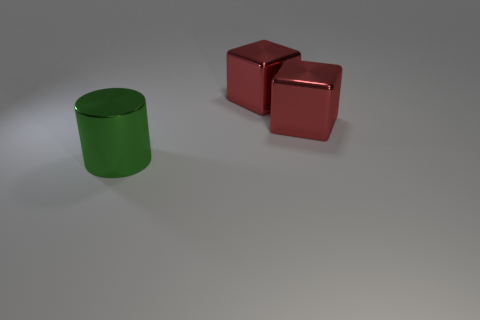What number of other objects are the same material as the green thing?
Offer a terse response. 2. What number of big objects are green cylinders or red objects?
Your answer should be very brief. 3. What number of red metallic blocks have the same size as the green shiny object?
Provide a short and direct response. 2. How many red things are either big metallic cubes or shiny cylinders?
Your answer should be very brief. 2. Are there an equal number of big metal objects on the left side of the large green cylinder and big gray rubber cubes?
Give a very brief answer. Yes. How many red things have the same shape as the large green object?
Keep it short and to the point. 0. How many small blue objects are there?
Make the answer very short. 0. How many metallic things are either blocks or green cylinders?
Give a very brief answer. 3. Is the number of large green cylinders less than the number of cubes?
Offer a terse response. Yes. Is there anything else of the same color as the large cylinder?
Give a very brief answer. No. 